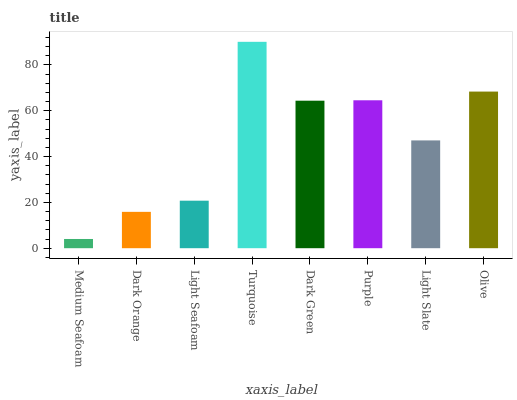Is Dark Orange the minimum?
Answer yes or no. No. Is Dark Orange the maximum?
Answer yes or no. No. Is Dark Orange greater than Medium Seafoam?
Answer yes or no. Yes. Is Medium Seafoam less than Dark Orange?
Answer yes or no. Yes. Is Medium Seafoam greater than Dark Orange?
Answer yes or no. No. Is Dark Orange less than Medium Seafoam?
Answer yes or no. No. Is Dark Green the high median?
Answer yes or no. Yes. Is Light Slate the low median?
Answer yes or no. Yes. Is Light Seafoam the high median?
Answer yes or no. No. Is Dark Green the low median?
Answer yes or no. No. 